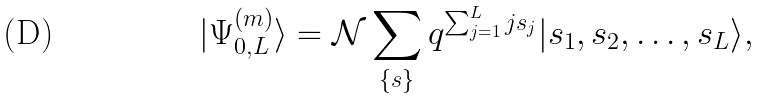<formula> <loc_0><loc_0><loc_500><loc_500>| \Psi _ { 0 , L } ^ { ( m ) } \rangle = \mathcal { N } \sum _ { \left \{ s \right \} } q ^ { \sum _ { j = 1 } ^ { L } j s _ { j } } | s _ { 1 } , s _ { 2 } , \dots , s _ { L } \rangle ,</formula> 